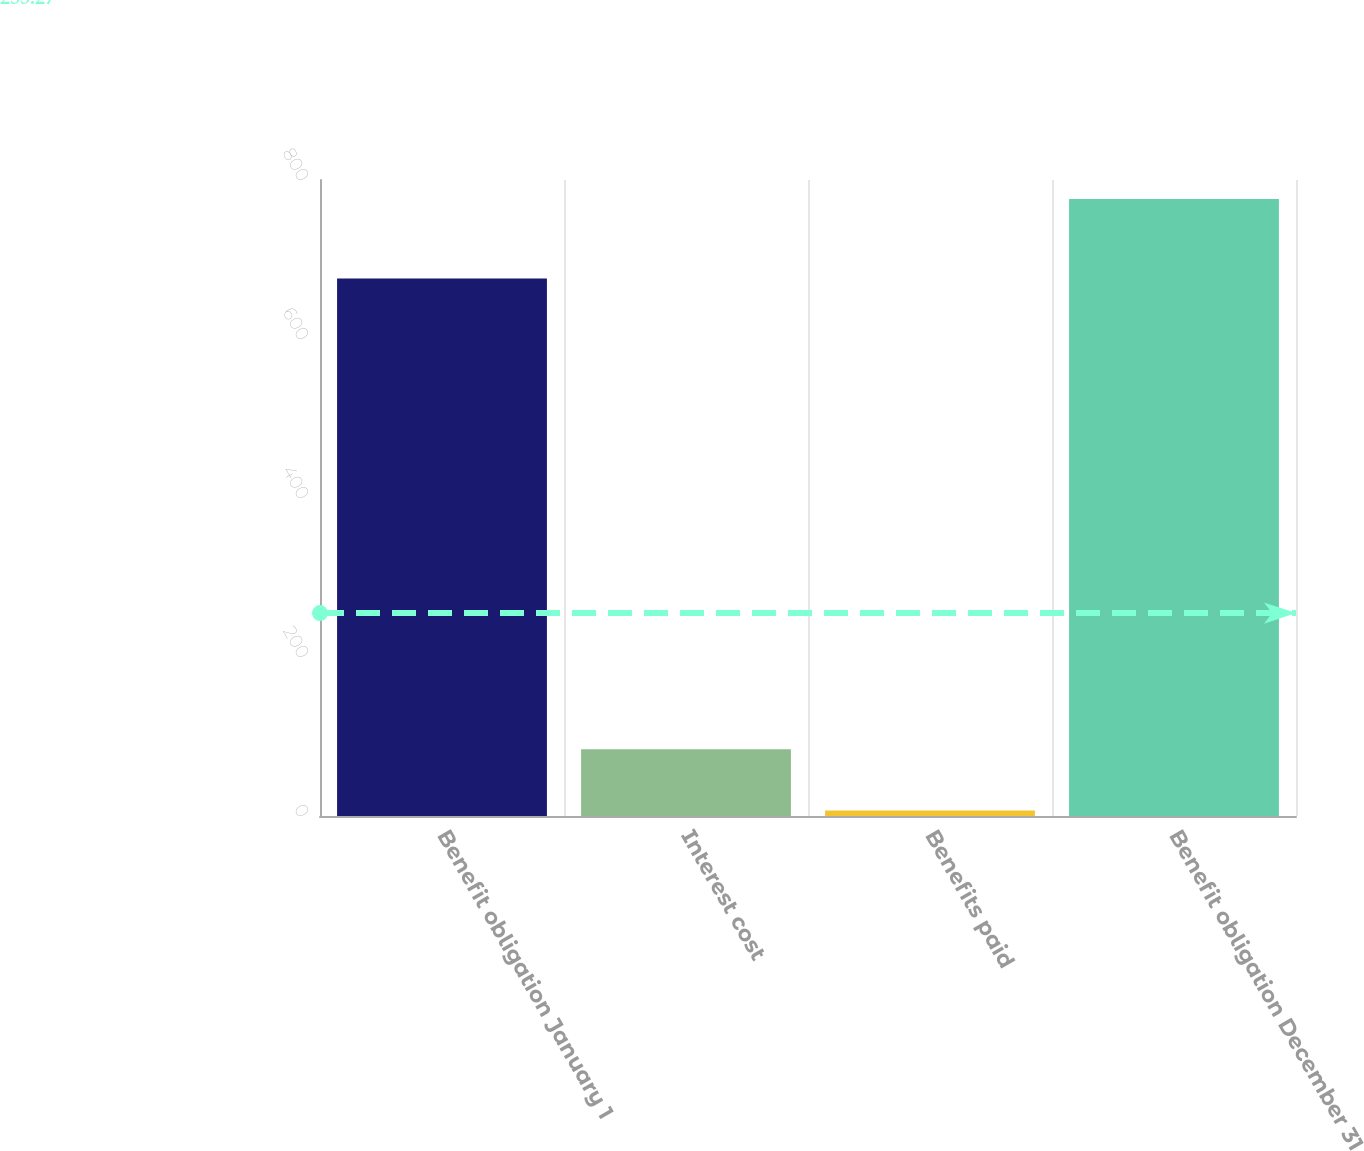Convert chart to OTSL. <chart><loc_0><loc_0><loc_500><loc_500><bar_chart><fcel>Benefit obligation January 1<fcel>Interest cost<fcel>Benefits paid<fcel>Benefit obligation December 31<nl><fcel>676<fcel>83.9<fcel>7<fcel>776<nl></chart> 